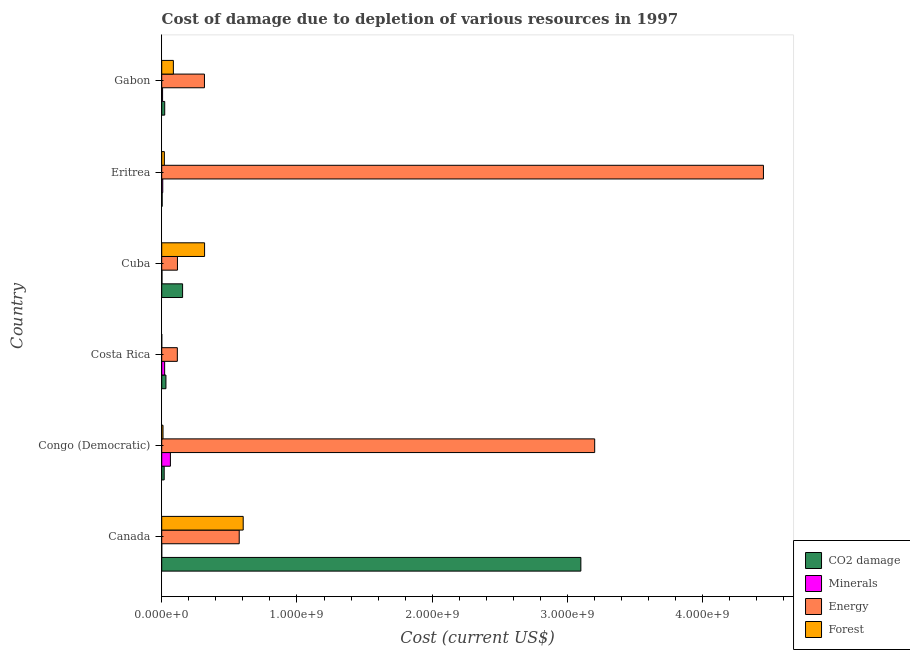Are the number of bars per tick equal to the number of legend labels?
Your answer should be compact. Yes. Are the number of bars on each tick of the Y-axis equal?
Ensure brevity in your answer.  Yes. How many bars are there on the 2nd tick from the top?
Make the answer very short. 4. How many bars are there on the 3rd tick from the bottom?
Ensure brevity in your answer.  4. In how many cases, is the number of bars for a given country not equal to the number of legend labels?
Offer a terse response. 0. What is the cost of damage due to depletion of forests in Cuba?
Ensure brevity in your answer.  3.17e+08. Across all countries, what is the maximum cost of damage due to depletion of forests?
Your answer should be very brief. 6.02e+08. Across all countries, what is the minimum cost of damage due to depletion of forests?
Provide a short and direct response. 3.15e+05. In which country was the cost of damage due to depletion of forests maximum?
Keep it short and to the point. Canada. In which country was the cost of damage due to depletion of coal minimum?
Give a very brief answer. Eritrea. What is the total cost of damage due to depletion of forests in the graph?
Your answer should be compact. 1.04e+09. What is the difference between the cost of damage due to depletion of forests in Cuba and that in Gabon?
Give a very brief answer. 2.31e+08. What is the difference between the cost of damage due to depletion of forests in Canada and the cost of damage due to depletion of energy in Cuba?
Offer a terse response. 4.86e+08. What is the average cost of damage due to depletion of coal per country?
Provide a short and direct response. 5.55e+08. What is the difference between the cost of damage due to depletion of coal and cost of damage due to depletion of energy in Cuba?
Your answer should be compact. 3.81e+07. In how many countries, is the cost of damage due to depletion of energy greater than 4200000000 US$?
Give a very brief answer. 1. What is the ratio of the cost of damage due to depletion of energy in Eritrea to that in Gabon?
Make the answer very short. 14.08. What is the difference between the highest and the second highest cost of damage due to depletion of forests?
Provide a succinct answer. 2.85e+08. What is the difference between the highest and the lowest cost of damage due to depletion of forests?
Offer a very short reply. 6.02e+08. In how many countries, is the cost of damage due to depletion of coal greater than the average cost of damage due to depletion of coal taken over all countries?
Offer a very short reply. 1. What does the 4th bar from the top in Costa Rica represents?
Your response must be concise. CO2 damage. What does the 2nd bar from the bottom in Eritrea represents?
Offer a very short reply. Minerals. How many bars are there?
Your answer should be compact. 24. Are all the bars in the graph horizontal?
Provide a short and direct response. Yes. Does the graph contain any zero values?
Your answer should be very brief. No. Does the graph contain grids?
Your answer should be very brief. No. How many legend labels are there?
Make the answer very short. 4. What is the title of the graph?
Provide a succinct answer. Cost of damage due to depletion of various resources in 1997 . What is the label or title of the X-axis?
Your response must be concise. Cost (current US$). What is the Cost (current US$) in CO2 damage in Canada?
Your answer should be very brief. 3.10e+09. What is the Cost (current US$) in Minerals in Canada?
Offer a very short reply. 9.36e+04. What is the Cost (current US$) of Energy in Canada?
Ensure brevity in your answer.  5.73e+08. What is the Cost (current US$) of Forest in Canada?
Ensure brevity in your answer.  6.02e+08. What is the Cost (current US$) in CO2 damage in Congo (Democratic)?
Give a very brief answer. 1.83e+07. What is the Cost (current US$) in Minerals in Congo (Democratic)?
Your response must be concise. 6.43e+07. What is the Cost (current US$) of Energy in Congo (Democratic)?
Keep it short and to the point. 3.20e+09. What is the Cost (current US$) of Forest in Congo (Democratic)?
Provide a succinct answer. 9.67e+06. What is the Cost (current US$) in CO2 damage in Costa Rica?
Provide a succinct answer. 3.12e+07. What is the Cost (current US$) of Minerals in Costa Rica?
Offer a terse response. 2.17e+07. What is the Cost (current US$) in Energy in Costa Rica?
Provide a short and direct response. 1.15e+08. What is the Cost (current US$) of Forest in Costa Rica?
Offer a terse response. 3.15e+05. What is the Cost (current US$) in CO2 damage in Cuba?
Offer a very short reply. 1.54e+08. What is the Cost (current US$) of Minerals in Cuba?
Offer a terse response. 2.01e+06. What is the Cost (current US$) of Energy in Cuba?
Your answer should be very brief. 1.16e+08. What is the Cost (current US$) in Forest in Cuba?
Ensure brevity in your answer.  3.17e+08. What is the Cost (current US$) of CO2 damage in Eritrea?
Provide a succinct answer. 3.31e+06. What is the Cost (current US$) in Minerals in Eritrea?
Offer a terse response. 7.71e+06. What is the Cost (current US$) in Energy in Eritrea?
Give a very brief answer. 4.45e+09. What is the Cost (current US$) of Forest in Eritrea?
Make the answer very short. 1.96e+07. What is the Cost (current US$) of CO2 damage in Gabon?
Your answer should be compact. 2.22e+07. What is the Cost (current US$) in Minerals in Gabon?
Offer a terse response. 6.37e+06. What is the Cost (current US$) of Energy in Gabon?
Make the answer very short. 3.16e+08. What is the Cost (current US$) in Forest in Gabon?
Provide a short and direct response. 8.62e+07. Across all countries, what is the maximum Cost (current US$) of CO2 damage?
Offer a very short reply. 3.10e+09. Across all countries, what is the maximum Cost (current US$) in Minerals?
Offer a terse response. 6.43e+07. Across all countries, what is the maximum Cost (current US$) of Energy?
Your response must be concise. 4.45e+09. Across all countries, what is the maximum Cost (current US$) in Forest?
Your answer should be very brief. 6.02e+08. Across all countries, what is the minimum Cost (current US$) in CO2 damage?
Ensure brevity in your answer.  3.31e+06. Across all countries, what is the minimum Cost (current US$) of Minerals?
Provide a short and direct response. 9.36e+04. Across all countries, what is the minimum Cost (current US$) in Energy?
Offer a terse response. 1.15e+08. Across all countries, what is the minimum Cost (current US$) in Forest?
Give a very brief answer. 3.15e+05. What is the total Cost (current US$) in CO2 damage in the graph?
Provide a short and direct response. 3.33e+09. What is the total Cost (current US$) of Minerals in the graph?
Your response must be concise. 1.02e+08. What is the total Cost (current US$) of Energy in the graph?
Provide a succinct answer. 8.77e+09. What is the total Cost (current US$) in Forest in the graph?
Provide a succinct answer. 1.04e+09. What is the difference between the Cost (current US$) of CO2 damage in Canada and that in Congo (Democratic)?
Provide a short and direct response. 3.08e+09. What is the difference between the Cost (current US$) in Minerals in Canada and that in Congo (Democratic)?
Ensure brevity in your answer.  -6.42e+07. What is the difference between the Cost (current US$) in Energy in Canada and that in Congo (Democratic)?
Make the answer very short. -2.63e+09. What is the difference between the Cost (current US$) in Forest in Canada and that in Congo (Democratic)?
Offer a very short reply. 5.93e+08. What is the difference between the Cost (current US$) of CO2 damage in Canada and that in Costa Rica?
Provide a short and direct response. 3.07e+09. What is the difference between the Cost (current US$) of Minerals in Canada and that in Costa Rica?
Keep it short and to the point. -2.16e+07. What is the difference between the Cost (current US$) of Energy in Canada and that in Costa Rica?
Offer a very short reply. 4.58e+08. What is the difference between the Cost (current US$) in Forest in Canada and that in Costa Rica?
Your answer should be very brief. 6.02e+08. What is the difference between the Cost (current US$) in CO2 damage in Canada and that in Cuba?
Offer a very short reply. 2.94e+09. What is the difference between the Cost (current US$) in Minerals in Canada and that in Cuba?
Ensure brevity in your answer.  -1.92e+06. What is the difference between the Cost (current US$) in Energy in Canada and that in Cuba?
Your answer should be compact. 4.57e+08. What is the difference between the Cost (current US$) of Forest in Canada and that in Cuba?
Provide a succinct answer. 2.85e+08. What is the difference between the Cost (current US$) in CO2 damage in Canada and that in Eritrea?
Keep it short and to the point. 3.10e+09. What is the difference between the Cost (current US$) of Minerals in Canada and that in Eritrea?
Your answer should be very brief. -7.62e+06. What is the difference between the Cost (current US$) in Energy in Canada and that in Eritrea?
Provide a succinct answer. -3.88e+09. What is the difference between the Cost (current US$) in Forest in Canada and that in Eritrea?
Provide a short and direct response. 5.83e+08. What is the difference between the Cost (current US$) in CO2 damage in Canada and that in Gabon?
Keep it short and to the point. 3.08e+09. What is the difference between the Cost (current US$) in Minerals in Canada and that in Gabon?
Your response must be concise. -6.28e+06. What is the difference between the Cost (current US$) of Energy in Canada and that in Gabon?
Offer a very short reply. 2.57e+08. What is the difference between the Cost (current US$) in Forest in Canada and that in Gabon?
Ensure brevity in your answer.  5.16e+08. What is the difference between the Cost (current US$) of CO2 damage in Congo (Democratic) and that in Costa Rica?
Make the answer very short. -1.29e+07. What is the difference between the Cost (current US$) of Minerals in Congo (Democratic) and that in Costa Rica?
Keep it short and to the point. 4.26e+07. What is the difference between the Cost (current US$) in Energy in Congo (Democratic) and that in Costa Rica?
Provide a succinct answer. 3.09e+09. What is the difference between the Cost (current US$) in Forest in Congo (Democratic) and that in Costa Rica?
Offer a very short reply. 9.36e+06. What is the difference between the Cost (current US$) of CO2 damage in Congo (Democratic) and that in Cuba?
Give a very brief answer. -1.36e+08. What is the difference between the Cost (current US$) of Minerals in Congo (Democratic) and that in Cuba?
Offer a very short reply. 6.23e+07. What is the difference between the Cost (current US$) in Energy in Congo (Democratic) and that in Cuba?
Keep it short and to the point. 3.08e+09. What is the difference between the Cost (current US$) in Forest in Congo (Democratic) and that in Cuba?
Provide a short and direct response. -3.07e+08. What is the difference between the Cost (current US$) of CO2 damage in Congo (Democratic) and that in Eritrea?
Make the answer very short. 1.50e+07. What is the difference between the Cost (current US$) in Minerals in Congo (Democratic) and that in Eritrea?
Give a very brief answer. 5.66e+07. What is the difference between the Cost (current US$) in Energy in Congo (Democratic) and that in Eritrea?
Offer a terse response. -1.25e+09. What is the difference between the Cost (current US$) of Forest in Congo (Democratic) and that in Eritrea?
Ensure brevity in your answer.  -9.94e+06. What is the difference between the Cost (current US$) of CO2 damage in Congo (Democratic) and that in Gabon?
Give a very brief answer. -3.88e+06. What is the difference between the Cost (current US$) in Minerals in Congo (Democratic) and that in Gabon?
Ensure brevity in your answer.  5.79e+07. What is the difference between the Cost (current US$) in Energy in Congo (Democratic) and that in Gabon?
Make the answer very short. 2.88e+09. What is the difference between the Cost (current US$) of Forest in Congo (Democratic) and that in Gabon?
Your response must be concise. -7.65e+07. What is the difference between the Cost (current US$) in CO2 damage in Costa Rica and that in Cuba?
Your response must be concise. -1.23e+08. What is the difference between the Cost (current US$) of Minerals in Costa Rica and that in Cuba?
Offer a terse response. 1.97e+07. What is the difference between the Cost (current US$) of Energy in Costa Rica and that in Cuba?
Your response must be concise. -9.28e+05. What is the difference between the Cost (current US$) in Forest in Costa Rica and that in Cuba?
Your response must be concise. -3.17e+08. What is the difference between the Cost (current US$) of CO2 damage in Costa Rica and that in Eritrea?
Offer a terse response. 2.79e+07. What is the difference between the Cost (current US$) in Minerals in Costa Rica and that in Eritrea?
Your response must be concise. 1.40e+07. What is the difference between the Cost (current US$) in Energy in Costa Rica and that in Eritrea?
Provide a succinct answer. -4.33e+09. What is the difference between the Cost (current US$) in Forest in Costa Rica and that in Eritrea?
Your answer should be compact. -1.93e+07. What is the difference between the Cost (current US$) in CO2 damage in Costa Rica and that in Gabon?
Give a very brief answer. 9.03e+06. What is the difference between the Cost (current US$) in Minerals in Costa Rica and that in Gabon?
Provide a succinct answer. 1.53e+07. What is the difference between the Cost (current US$) of Energy in Costa Rica and that in Gabon?
Provide a short and direct response. -2.01e+08. What is the difference between the Cost (current US$) of Forest in Costa Rica and that in Gabon?
Offer a terse response. -8.59e+07. What is the difference between the Cost (current US$) in CO2 damage in Cuba and that in Eritrea?
Offer a terse response. 1.51e+08. What is the difference between the Cost (current US$) in Minerals in Cuba and that in Eritrea?
Provide a succinct answer. -5.70e+06. What is the difference between the Cost (current US$) of Energy in Cuba and that in Eritrea?
Keep it short and to the point. -4.33e+09. What is the difference between the Cost (current US$) of Forest in Cuba and that in Eritrea?
Keep it short and to the point. 2.97e+08. What is the difference between the Cost (current US$) in CO2 damage in Cuba and that in Gabon?
Provide a short and direct response. 1.32e+08. What is the difference between the Cost (current US$) of Minerals in Cuba and that in Gabon?
Make the answer very short. -4.37e+06. What is the difference between the Cost (current US$) in Energy in Cuba and that in Gabon?
Give a very brief answer. -2.00e+08. What is the difference between the Cost (current US$) in Forest in Cuba and that in Gabon?
Offer a very short reply. 2.31e+08. What is the difference between the Cost (current US$) of CO2 damage in Eritrea and that in Gabon?
Your answer should be compact. -1.89e+07. What is the difference between the Cost (current US$) of Minerals in Eritrea and that in Gabon?
Your response must be concise. 1.33e+06. What is the difference between the Cost (current US$) in Energy in Eritrea and that in Gabon?
Provide a short and direct response. 4.13e+09. What is the difference between the Cost (current US$) in Forest in Eritrea and that in Gabon?
Make the answer very short. -6.66e+07. What is the difference between the Cost (current US$) in CO2 damage in Canada and the Cost (current US$) in Minerals in Congo (Democratic)?
Make the answer very short. 3.03e+09. What is the difference between the Cost (current US$) of CO2 damage in Canada and the Cost (current US$) of Energy in Congo (Democratic)?
Provide a short and direct response. -1.02e+08. What is the difference between the Cost (current US$) of CO2 damage in Canada and the Cost (current US$) of Forest in Congo (Democratic)?
Give a very brief answer. 3.09e+09. What is the difference between the Cost (current US$) in Minerals in Canada and the Cost (current US$) in Energy in Congo (Democratic)?
Your answer should be very brief. -3.20e+09. What is the difference between the Cost (current US$) of Minerals in Canada and the Cost (current US$) of Forest in Congo (Democratic)?
Your answer should be compact. -9.58e+06. What is the difference between the Cost (current US$) in Energy in Canada and the Cost (current US$) in Forest in Congo (Democratic)?
Provide a succinct answer. 5.63e+08. What is the difference between the Cost (current US$) in CO2 damage in Canada and the Cost (current US$) in Minerals in Costa Rica?
Your answer should be very brief. 3.08e+09. What is the difference between the Cost (current US$) of CO2 damage in Canada and the Cost (current US$) of Energy in Costa Rica?
Offer a terse response. 2.98e+09. What is the difference between the Cost (current US$) in CO2 damage in Canada and the Cost (current US$) in Forest in Costa Rica?
Your response must be concise. 3.10e+09. What is the difference between the Cost (current US$) in Minerals in Canada and the Cost (current US$) in Energy in Costa Rica?
Your answer should be compact. -1.15e+08. What is the difference between the Cost (current US$) in Minerals in Canada and the Cost (current US$) in Forest in Costa Rica?
Offer a very short reply. -2.21e+05. What is the difference between the Cost (current US$) in Energy in Canada and the Cost (current US$) in Forest in Costa Rica?
Keep it short and to the point. 5.73e+08. What is the difference between the Cost (current US$) in CO2 damage in Canada and the Cost (current US$) in Minerals in Cuba?
Offer a very short reply. 3.10e+09. What is the difference between the Cost (current US$) of CO2 damage in Canada and the Cost (current US$) of Energy in Cuba?
Give a very brief answer. 2.98e+09. What is the difference between the Cost (current US$) in CO2 damage in Canada and the Cost (current US$) in Forest in Cuba?
Provide a short and direct response. 2.78e+09. What is the difference between the Cost (current US$) of Minerals in Canada and the Cost (current US$) of Energy in Cuba?
Your answer should be very brief. -1.16e+08. What is the difference between the Cost (current US$) of Minerals in Canada and the Cost (current US$) of Forest in Cuba?
Give a very brief answer. -3.17e+08. What is the difference between the Cost (current US$) of Energy in Canada and the Cost (current US$) of Forest in Cuba?
Offer a very short reply. 2.56e+08. What is the difference between the Cost (current US$) of CO2 damage in Canada and the Cost (current US$) of Minerals in Eritrea?
Offer a very short reply. 3.09e+09. What is the difference between the Cost (current US$) in CO2 damage in Canada and the Cost (current US$) in Energy in Eritrea?
Your response must be concise. -1.35e+09. What is the difference between the Cost (current US$) of CO2 damage in Canada and the Cost (current US$) of Forest in Eritrea?
Offer a terse response. 3.08e+09. What is the difference between the Cost (current US$) of Minerals in Canada and the Cost (current US$) of Energy in Eritrea?
Provide a succinct answer. -4.45e+09. What is the difference between the Cost (current US$) in Minerals in Canada and the Cost (current US$) in Forest in Eritrea?
Your response must be concise. -1.95e+07. What is the difference between the Cost (current US$) of Energy in Canada and the Cost (current US$) of Forest in Eritrea?
Your response must be concise. 5.53e+08. What is the difference between the Cost (current US$) of CO2 damage in Canada and the Cost (current US$) of Minerals in Gabon?
Give a very brief answer. 3.09e+09. What is the difference between the Cost (current US$) in CO2 damage in Canada and the Cost (current US$) in Energy in Gabon?
Provide a short and direct response. 2.78e+09. What is the difference between the Cost (current US$) in CO2 damage in Canada and the Cost (current US$) in Forest in Gabon?
Provide a short and direct response. 3.01e+09. What is the difference between the Cost (current US$) of Minerals in Canada and the Cost (current US$) of Energy in Gabon?
Make the answer very short. -3.16e+08. What is the difference between the Cost (current US$) in Minerals in Canada and the Cost (current US$) in Forest in Gabon?
Keep it short and to the point. -8.61e+07. What is the difference between the Cost (current US$) in Energy in Canada and the Cost (current US$) in Forest in Gabon?
Your answer should be very brief. 4.87e+08. What is the difference between the Cost (current US$) in CO2 damage in Congo (Democratic) and the Cost (current US$) in Minerals in Costa Rica?
Ensure brevity in your answer.  -3.34e+06. What is the difference between the Cost (current US$) in CO2 damage in Congo (Democratic) and the Cost (current US$) in Energy in Costa Rica?
Your answer should be compact. -9.71e+07. What is the difference between the Cost (current US$) in CO2 damage in Congo (Democratic) and the Cost (current US$) in Forest in Costa Rica?
Ensure brevity in your answer.  1.80e+07. What is the difference between the Cost (current US$) in Minerals in Congo (Democratic) and the Cost (current US$) in Energy in Costa Rica?
Your answer should be very brief. -5.11e+07. What is the difference between the Cost (current US$) of Minerals in Congo (Democratic) and the Cost (current US$) of Forest in Costa Rica?
Your answer should be very brief. 6.40e+07. What is the difference between the Cost (current US$) in Energy in Congo (Democratic) and the Cost (current US$) in Forest in Costa Rica?
Your answer should be compact. 3.20e+09. What is the difference between the Cost (current US$) in CO2 damage in Congo (Democratic) and the Cost (current US$) in Minerals in Cuba?
Keep it short and to the point. 1.63e+07. What is the difference between the Cost (current US$) in CO2 damage in Congo (Democratic) and the Cost (current US$) in Energy in Cuba?
Your answer should be very brief. -9.80e+07. What is the difference between the Cost (current US$) of CO2 damage in Congo (Democratic) and the Cost (current US$) of Forest in Cuba?
Provide a succinct answer. -2.99e+08. What is the difference between the Cost (current US$) of Minerals in Congo (Democratic) and the Cost (current US$) of Energy in Cuba?
Make the answer very short. -5.20e+07. What is the difference between the Cost (current US$) of Minerals in Congo (Democratic) and the Cost (current US$) of Forest in Cuba?
Ensure brevity in your answer.  -2.53e+08. What is the difference between the Cost (current US$) in Energy in Congo (Democratic) and the Cost (current US$) in Forest in Cuba?
Give a very brief answer. 2.88e+09. What is the difference between the Cost (current US$) of CO2 damage in Congo (Democratic) and the Cost (current US$) of Minerals in Eritrea?
Your answer should be very brief. 1.06e+07. What is the difference between the Cost (current US$) in CO2 damage in Congo (Democratic) and the Cost (current US$) in Energy in Eritrea?
Ensure brevity in your answer.  -4.43e+09. What is the difference between the Cost (current US$) in CO2 damage in Congo (Democratic) and the Cost (current US$) in Forest in Eritrea?
Your answer should be compact. -1.28e+06. What is the difference between the Cost (current US$) of Minerals in Congo (Democratic) and the Cost (current US$) of Energy in Eritrea?
Ensure brevity in your answer.  -4.38e+09. What is the difference between the Cost (current US$) of Minerals in Congo (Democratic) and the Cost (current US$) of Forest in Eritrea?
Give a very brief answer. 4.47e+07. What is the difference between the Cost (current US$) in Energy in Congo (Democratic) and the Cost (current US$) in Forest in Eritrea?
Ensure brevity in your answer.  3.18e+09. What is the difference between the Cost (current US$) in CO2 damage in Congo (Democratic) and the Cost (current US$) in Minerals in Gabon?
Keep it short and to the point. 1.20e+07. What is the difference between the Cost (current US$) of CO2 damage in Congo (Democratic) and the Cost (current US$) of Energy in Gabon?
Provide a short and direct response. -2.98e+08. What is the difference between the Cost (current US$) in CO2 damage in Congo (Democratic) and the Cost (current US$) in Forest in Gabon?
Make the answer very short. -6.79e+07. What is the difference between the Cost (current US$) of Minerals in Congo (Democratic) and the Cost (current US$) of Energy in Gabon?
Offer a very short reply. -2.52e+08. What is the difference between the Cost (current US$) of Minerals in Congo (Democratic) and the Cost (current US$) of Forest in Gabon?
Ensure brevity in your answer.  -2.19e+07. What is the difference between the Cost (current US$) of Energy in Congo (Democratic) and the Cost (current US$) of Forest in Gabon?
Your response must be concise. 3.11e+09. What is the difference between the Cost (current US$) in CO2 damage in Costa Rica and the Cost (current US$) in Minerals in Cuba?
Keep it short and to the point. 2.92e+07. What is the difference between the Cost (current US$) in CO2 damage in Costa Rica and the Cost (current US$) in Energy in Cuba?
Make the answer very short. -8.51e+07. What is the difference between the Cost (current US$) in CO2 damage in Costa Rica and the Cost (current US$) in Forest in Cuba?
Provide a short and direct response. -2.86e+08. What is the difference between the Cost (current US$) of Minerals in Costa Rica and the Cost (current US$) of Energy in Cuba?
Keep it short and to the point. -9.47e+07. What is the difference between the Cost (current US$) in Minerals in Costa Rica and the Cost (current US$) in Forest in Cuba?
Ensure brevity in your answer.  -2.95e+08. What is the difference between the Cost (current US$) in Energy in Costa Rica and the Cost (current US$) in Forest in Cuba?
Provide a short and direct response. -2.02e+08. What is the difference between the Cost (current US$) of CO2 damage in Costa Rica and the Cost (current US$) of Minerals in Eritrea?
Your response must be concise. 2.35e+07. What is the difference between the Cost (current US$) in CO2 damage in Costa Rica and the Cost (current US$) in Energy in Eritrea?
Your answer should be very brief. -4.42e+09. What is the difference between the Cost (current US$) in CO2 damage in Costa Rica and the Cost (current US$) in Forest in Eritrea?
Offer a very short reply. 1.16e+07. What is the difference between the Cost (current US$) of Minerals in Costa Rica and the Cost (current US$) of Energy in Eritrea?
Your answer should be compact. -4.43e+09. What is the difference between the Cost (current US$) of Minerals in Costa Rica and the Cost (current US$) of Forest in Eritrea?
Provide a succinct answer. 2.06e+06. What is the difference between the Cost (current US$) of Energy in Costa Rica and the Cost (current US$) of Forest in Eritrea?
Your answer should be compact. 9.58e+07. What is the difference between the Cost (current US$) of CO2 damage in Costa Rica and the Cost (current US$) of Minerals in Gabon?
Your answer should be compact. 2.49e+07. What is the difference between the Cost (current US$) of CO2 damage in Costa Rica and the Cost (current US$) of Energy in Gabon?
Provide a short and direct response. -2.85e+08. What is the difference between the Cost (current US$) of CO2 damage in Costa Rica and the Cost (current US$) of Forest in Gabon?
Offer a terse response. -5.50e+07. What is the difference between the Cost (current US$) in Minerals in Costa Rica and the Cost (current US$) in Energy in Gabon?
Ensure brevity in your answer.  -2.94e+08. What is the difference between the Cost (current US$) of Minerals in Costa Rica and the Cost (current US$) of Forest in Gabon?
Keep it short and to the point. -6.45e+07. What is the difference between the Cost (current US$) in Energy in Costa Rica and the Cost (current US$) in Forest in Gabon?
Provide a short and direct response. 2.92e+07. What is the difference between the Cost (current US$) in CO2 damage in Cuba and the Cost (current US$) in Minerals in Eritrea?
Your response must be concise. 1.47e+08. What is the difference between the Cost (current US$) of CO2 damage in Cuba and the Cost (current US$) of Energy in Eritrea?
Your response must be concise. -4.29e+09. What is the difference between the Cost (current US$) in CO2 damage in Cuba and the Cost (current US$) in Forest in Eritrea?
Your response must be concise. 1.35e+08. What is the difference between the Cost (current US$) of Minerals in Cuba and the Cost (current US$) of Energy in Eritrea?
Offer a very short reply. -4.45e+09. What is the difference between the Cost (current US$) of Minerals in Cuba and the Cost (current US$) of Forest in Eritrea?
Offer a terse response. -1.76e+07. What is the difference between the Cost (current US$) of Energy in Cuba and the Cost (current US$) of Forest in Eritrea?
Your answer should be very brief. 9.67e+07. What is the difference between the Cost (current US$) of CO2 damage in Cuba and the Cost (current US$) of Minerals in Gabon?
Your response must be concise. 1.48e+08. What is the difference between the Cost (current US$) of CO2 damage in Cuba and the Cost (current US$) of Energy in Gabon?
Make the answer very short. -1.62e+08. What is the difference between the Cost (current US$) of CO2 damage in Cuba and the Cost (current US$) of Forest in Gabon?
Offer a very short reply. 6.82e+07. What is the difference between the Cost (current US$) of Minerals in Cuba and the Cost (current US$) of Energy in Gabon?
Provide a succinct answer. -3.14e+08. What is the difference between the Cost (current US$) of Minerals in Cuba and the Cost (current US$) of Forest in Gabon?
Offer a very short reply. -8.42e+07. What is the difference between the Cost (current US$) in Energy in Cuba and the Cost (current US$) in Forest in Gabon?
Your response must be concise. 3.01e+07. What is the difference between the Cost (current US$) in CO2 damage in Eritrea and the Cost (current US$) in Minerals in Gabon?
Your response must be concise. -3.07e+06. What is the difference between the Cost (current US$) of CO2 damage in Eritrea and the Cost (current US$) of Energy in Gabon?
Offer a terse response. -3.13e+08. What is the difference between the Cost (current US$) of CO2 damage in Eritrea and the Cost (current US$) of Forest in Gabon?
Ensure brevity in your answer.  -8.29e+07. What is the difference between the Cost (current US$) in Minerals in Eritrea and the Cost (current US$) in Energy in Gabon?
Offer a very short reply. -3.08e+08. What is the difference between the Cost (current US$) of Minerals in Eritrea and the Cost (current US$) of Forest in Gabon?
Provide a succinct answer. -7.85e+07. What is the difference between the Cost (current US$) in Energy in Eritrea and the Cost (current US$) in Forest in Gabon?
Ensure brevity in your answer.  4.36e+09. What is the average Cost (current US$) of CO2 damage per country?
Give a very brief answer. 5.55e+08. What is the average Cost (current US$) in Minerals per country?
Your answer should be compact. 1.70e+07. What is the average Cost (current US$) of Energy per country?
Keep it short and to the point. 1.46e+09. What is the average Cost (current US$) of Forest per country?
Keep it short and to the point. 1.73e+08. What is the difference between the Cost (current US$) in CO2 damage and Cost (current US$) in Minerals in Canada?
Provide a short and direct response. 3.10e+09. What is the difference between the Cost (current US$) of CO2 damage and Cost (current US$) of Energy in Canada?
Provide a short and direct response. 2.53e+09. What is the difference between the Cost (current US$) in CO2 damage and Cost (current US$) in Forest in Canada?
Provide a succinct answer. 2.50e+09. What is the difference between the Cost (current US$) in Minerals and Cost (current US$) in Energy in Canada?
Your answer should be very brief. -5.73e+08. What is the difference between the Cost (current US$) of Minerals and Cost (current US$) of Forest in Canada?
Ensure brevity in your answer.  -6.02e+08. What is the difference between the Cost (current US$) of Energy and Cost (current US$) of Forest in Canada?
Provide a succinct answer. -2.95e+07. What is the difference between the Cost (current US$) of CO2 damage and Cost (current US$) of Minerals in Congo (Democratic)?
Offer a very short reply. -4.60e+07. What is the difference between the Cost (current US$) in CO2 damage and Cost (current US$) in Energy in Congo (Democratic)?
Your answer should be compact. -3.18e+09. What is the difference between the Cost (current US$) in CO2 damage and Cost (current US$) in Forest in Congo (Democratic)?
Provide a short and direct response. 8.66e+06. What is the difference between the Cost (current US$) of Minerals and Cost (current US$) of Energy in Congo (Democratic)?
Provide a short and direct response. -3.14e+09. What is the difference between the Cost (current US$) in Minerals and Cost (current US$) in Forest in Congo (Democratic)?
Ensure brevity in your answer.  5.46e+07. What is the difference between the Cost (current US$) of Energy and Cost (current US$) of Forest in Congo (Democratic)?
Your answer should be very brief. 3.19e+09. What is the difference between the Cost (current US$) in CO2 damage and Cost (current US$) in Minerals in Costa Rica?
Your response must be concise. 9.57e+06. What is the difference between the Cost (current US$) in CO2 damage and Cost (current US$) in Energy in Costa Rica?
Ensure brevity in your answer.  -8.41e+07. What is the difference between the Cost (current US$) in CO2 damage and Cost (current US$) in Forest in Costa Rica?
Your response must be concise. 3.09e+07. What is the difference between the Cost (current US$) of Minerals and Cost (current US$) of Energy in Costa Rica?
Provide a short and direct response. -9.37e+07. What is the difference between the Cost (current US$) in Minerals and Cost (current US$) in Forest in Costa Rica?
Your answer should be very brief. 2.14e+07. What is the difference between the Cost (current US$) of Energy and Cost (current US$) of Forest in Costa Rica?
Ensure brevity in your answer.  1.15e+08. What is the difference between the Cost (current US$) of CO2 damage and Cost (current US$) of Minerals in Cuba?
Give a very brief answer. 1.52e+08. What is the difference between the Cost (current US$) in CO2 damage and Cost (current US$) in Energy in Cuba?
Offer a terse response. 3.81e+07. What is the difference between the Cost (current US$) in CO2 damage and Cost (current US$) in Forest in Cuba?
Make the answer very short. -1.63e+08. What is the difference between the Cost (current US$) in Minerals and Cost (current US$) in Energy in Cuba?
Your answer should be compact. -1.14e+08. What is the difference between the Cost (current US$) in Minerals and Cost (current US$) in Forest in Cuba?
Provide a short and direct response. -3.15e+08. What is the difference between the Cost (current US$) in Energy and Cost (current US$) in Forest in Cuba?
Keep it short and to the point. -2.01e+08. What is the difference between the Cost (current US$) of CO2 damage and Cost (current US$) of Minerals in Eritrea?
Give a very brief answer. -4.40e+06. What is the difference between the Cost (current US$) of CO2 damage and Cost (current US$) of Energy in Eritrea?
Your answer should be compact. -4.45e+09. What is the difference between the Cost (current US$) of CO2 damage and Cost (current US$) of Forest in Eritrea?
Provide a short and direct response. -1.63e+07. What is the difference between the Cost (current US$) of Minerals and Cost (current US$) of Energy in Eritrea?
Offer a very short reply. -4.44e+09. What is the difference between the Cost (current US$) of Minerals and Cost (current US$) of Forest in Eritrea?
Your answer should be compact. -1.19e+07. What is the difference between the Cost (current US$) of Energy and Cost (current US$) of Forest in Eritrea?
Your answer should be very brief. 4.43e+09. What is the difference between the Cost (current US$) of CO2 damage and Cost (current US$) of Minerals in Gabon?
Offer a very short reply. 1.58e+07. What is the difference between the Cost (current US$) in CO2 damage and Cost (current US$) in Energy in Gabon?
Make the answer very short. -2.94e+08. What is the difference between the Cost (current US$) in CO2 damage and Cost (current US$) in Forest in Gabon?
Provide a succinct answer. -6.40e+07. What is the difference between the Cost (current US$) in Minerals and Cost (current US$) in Energy in Gabon?
Your answer should be very brief. -3.10e+08. What is the difference between the Cost (current US$) in Minerals and Cost (current US$) in Forest in Gabon?
Offer a very short reply. -7.98e+07. What is the difference between the Cost (current US$) of Energy and Cost (current US$) of Forest in Gabon?
Make the answer very short. 2.30e+08. What is the ratio of the Cost (current US$) in CO2 damage in Canada to that in Congo (Democratic)?
Make the answer very short. 169.02. What is the ratio of the Cost (current US$) in Minerals in Canada to that in Congo (Democratic)?
Keep it short and to the point. 0. What is the ratio of the Cost (current US$) of Energy in Canada to that in Congo (Democratic)?
Offer a very short reply. 0.18. What is the ratio of the Cost (current US$) in Forest in Canada to that in Congo (Democratic)?
Offer a terse response. 62.28. What is the ratio of the Cost (current US$) in CO2 damage in Canada to that in Costa Rica?
Keep it short and to the point. 99.18. What is the ratio of the Cost (current US$) of Minerals in Canada to that in Costa Rica?
Give a very brief answer. 0. What is the ratio of the Cost (current US$) in Energy in Canada to that in Costa Rica?
Give a very brief answer. 4.97. What is the ratio of the Cost (current US$) of Forest in Canada to that in Costa Rica?
Your response must be concise. 1914.83. What is the ratio of the Cost (current US$) in CO2 damage in Canada to that in Cuba?
Offer a very short reply. 20.07. What is the ratio of the Cost (current US$) of Minerals in Canada to that in Cuba?
Provide a short and direct response. 0.05. What is the ratio of the Cost (current US$) of Energy in Canada to that in Cuba?
Offer a very short reply. 4.93. What is the ratio of the Cost (current US$) in Forest in Canada to that in Cuba?
Provide a succinct answer. 1.9. What is the ratio of the Cost (current US$) in CO2 damage in Canada to that in Eritrea?
Provide a succinct answer. 936.66. What is the ratio of the Cost (current US$) of Minerals in Canada to that in Eritrea?
Offer a very short reply. 0.01. What is the ratio of the Cost (current US$) in Energy in Canada to that in Eritrea?
Your answer should be compact. 0.13. What is the ratio of the Cost (current US$) in Forest in Canada to that in Eritrea?
Your answer should be very brief. 30.71. What is the ratio of the Cost (current US$) in CO2 damage in Canada to that in Gabon?
Provide a short and direct response. 139.48. What is the ratio of the Cost (current US$) of Minerals in Canada to that in Gabon?
Your answer should be compact. 0.01. What is the ratio of the Cost (current US$) of Energy in Canada to that in Gabon?
Offer a very short reply. 1.81. What is the ratio of the Cost (current US$) in Forest in Canada to that in Gabon?
Make the answer very short. 6.99. What is the ratio of the Cost (current US$) of CO2 damage in Congo (Democratic) to that in Costa Rica?
Provide a short and direct response. 0.59. What is the ratio of the Cost (current US$) of Minerals in Congo (Democratic) to that in Costa Rica?
Make the answer very short. 2.97. What is the ratio of the Cost (current US$) of Energy in Congo (Democratic) to that in Costa Rica?
Your answer should be very brief. 27.74. What is the ratio of the Cost (current US$) of Forest in Congo (Democratic) to that in Costa Rica?
Your answer should be compact. 30.75. What is the ratio of the Cost (current US$) of CO2 damage in Congo (Democratic) to that in Cuba?
Your answer should be compact. 0.12. What is the ratio of the Cost (current US$) of Minerals in Congo (Democratic) to that in Cuba?
Make the answer very short. 32.01. What is the ratio of the Cost (current US$) of Energy in Congo (Democratic) to that in Cuba?
Provide a short and direct response. 27.52. What is the ratio of the Cost (current US$) of Forest in Congo (Democratic) to that in Cuba?
Provide a succinct answer. 0.03. What is the ratio of the Cost (current US$) of CO2 damage in Congo (Democratic) to that in Eritrea?
Your answer should be compact. 5.54. What is the ratio of the Cost (current US$) in Minerals in Congo (Democratic) to that in Eritrea?
Give a very brief answer. 8.34. What is the ratio of the Cost (current US$) of Energy in Congo (Democratic) to that in Eritrea?
Your response must be concise. 0.72. What is the ratio of the Cost (current US$) in Forest in Congo (Democratic) to that in Eritrea?
Offer a very short reply. 0.49. What is the ratio of the Cost (current US$) of CO2 damage in Congo (Democratic) to that in Gabon?
Give a very brief answer. 0.83. What is the ratio of the Cost (current US$) in Minerals in Congo (Democratic) to that in Gabon?
Ensure brevity in your answer.  10.09. What is the ratio of the Cost (current US$) in Energy in Congo (Democratic) to that in Gabon?
Keep it short and to the point. 10.13. What is the ratio of the Cost (current US$) in Forest in Congo (Democratic) to that in Gabon?
Make the answer very short. 0.11. What is the ratio of the Cost (current US$) of CO2 damage in Costa Rica to that in Cuba?
Your answer should be very brief. 0.2. What is the ratio of the Cost (current US$) in Minerals in Costa Rica to that in Cuba?
Provide a succinct answer. 10.79. What is the ratio of the Cost (current US$) in Forest in Costa Rica to that in Cuba?
Make the answer very short. 0. What is the ratio of the Cost (current US$) of CO2 damage in Costa Rica to that in Eritrea?
Your answer should be compact. 9.44. What is the ratio of the Cost (current US$) in Minerals in Costa Rica to that in Eritrea?
Keep it short and to the point. 2.81. What is the ratio of the Cost (current US$) in Energy in Costa Rica to that in Eritrea?
Your response must be concise. 0.03. What is the ratio of the Cost (current US$) in Forest in Costa Rica to that in Eritrea?
Make the answer very short. 0.02. What is the ratio of the Cost (current US$) of CO2 damage in Costa Rica to that in Gabon?
Offer a terse response. 1.41. What is the ratio of the Cost (current US$) in Minerals in Costa Rica to that in Gabon?
Your answer should be very brief. 3.4. What is the ratio of the Cost (current US$) of Energy in Costa Rica to that in Gabon?
Offer a very short reply. 0.37. What is the ratio of the Cost (current US$) of Forest in Costa Rica to that in Gabon?
Give a very brief answer. 0. What is the ratio of the Cost (current US$) in CO2 damage in Cuba to that in Eritrea?
Ensure brevity in your answer.  46.68. What is the ratio of the Cost (current US$) in Minerals in Cuba to that in Eritrea?
Provide a short and direct response. 0.26. What is the ratio of the Cost (current US$) in Energy in Cuba to that in Eritrea?
Offer a very short reply. 0.03. What is the ratio of the Cost (current US$) of Forest in Cuba to that in Eritrea?
Provide a short and direct response. 16.16. What is the ratio of the Cost (current US$) of CO2 damage in Cuba to that in Gabon?
Your answer should be very brief. 6.95. What is the ratio of the Cost (current US$) of Minerals in Cuba to that in Gabon?
Keep it short and to the point. 0.32. What is the ratio of the Cost (current US$) in Energy in Cuba to that in Gabon?
Your answer should be compact. 0.37. What is the ratio of the Cost (current US$) in Forest in Cuba to that in Gabon?
Provide a succinct answer. 3.68. What is the ratio of the Cost (current US$) of CO2 damage in Eritrea to that in Gabon?
Your answer should be compact. 0.15. What is the ratio of the Cost (current US$) of Minerals in Eritrea to that in Gabon?
Your answer should be compact. 1.21. What is the ratio of the Cost (current US$) of Energy in Eritrea to that in Gabon?
Offer a terse response. 14.08. What is the ratio of the Cost (current US$) in Forest in Eritrea to that in Gabon?
Give a very brief answer. 0.23. What is the difference between the highest and the second highest Cost (current US$) of CO2 damage?
Offer a very short reply. 2.94e+09. What is the difference between the highest and the second highest Cost (current US$) in Minerals?
Your response must be concise. 4.26e+07. What is the difference between the highest and the second highest Cost (current US$) of Energy?
Make the answer very short. 1.25e+09. What is the difference between the highest and the second highest Cost (current US$) of Forest?
Your answer should be very brief. 2.85e+08. What is the difference between the highest and the lowest Cost (current US$) of CO2 damage?
Provide a succinct answer. 3.10e+09. What is the difference between the highest and the lowest Cost (current US$) of Minerals?
Provide a succinct answer. 6.42e+07. What is the difference between the highest and the lowest Cost (current US$) of Energy?
Give a very brief answer. 4.33e+09. What is the difference between the highest and the lowest Cost (current US$) of Forest?
Your answer should be compact. 6.02e+08. 